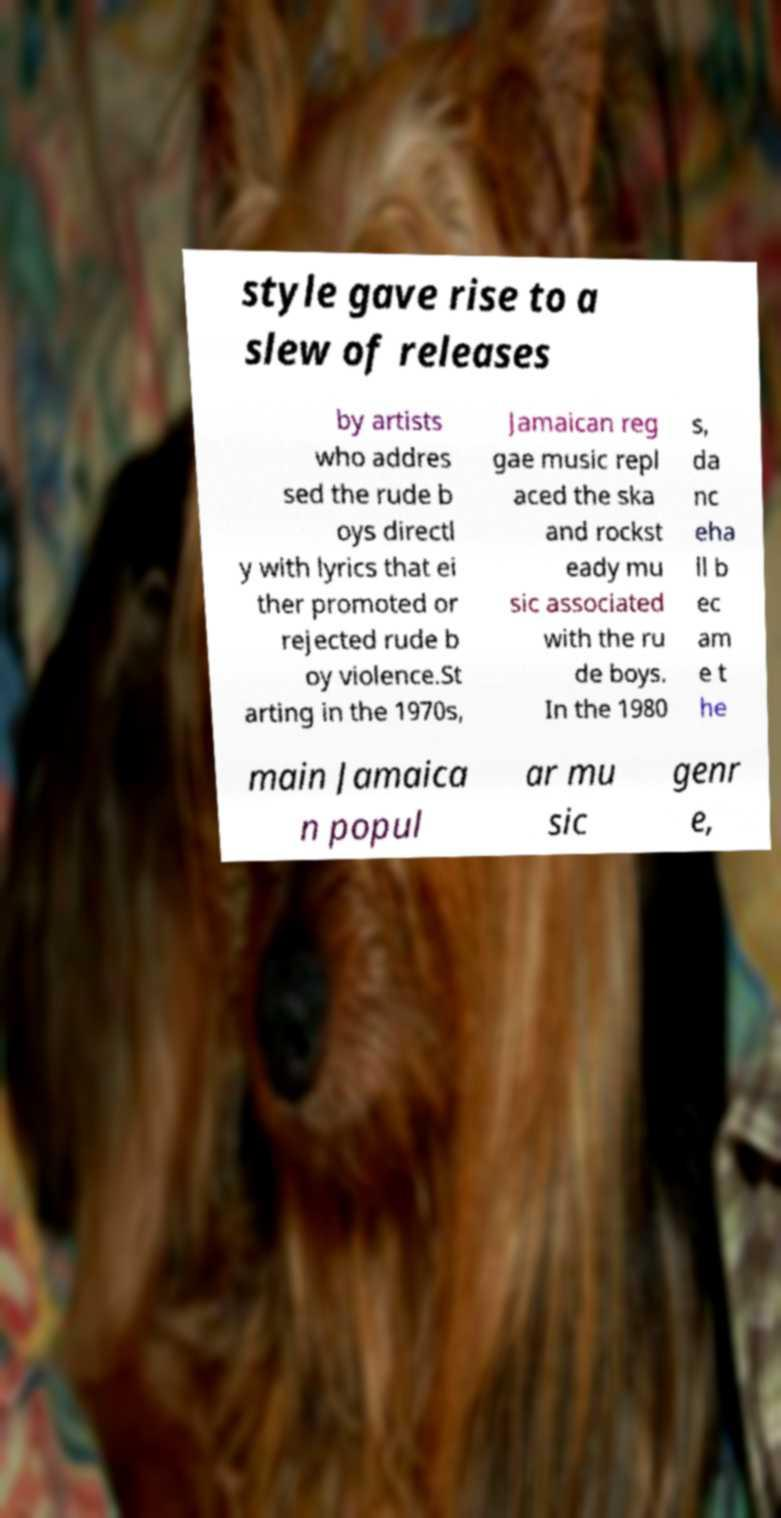Could you extract and type out the text from this image? style gave rise to a slew of releases by artists who addres sed the rude b oys directl y with lyrics that ei ther promoted or rejected rude b oy violence.St arting in the 1970s, Jamaican reg gae music repl aced the ska and rockst eady mu sic associated with the ru de boys. In the 1980 s, da nc eha ll b ec am e t he main Jamaica n popul ar mu sic genr e, 